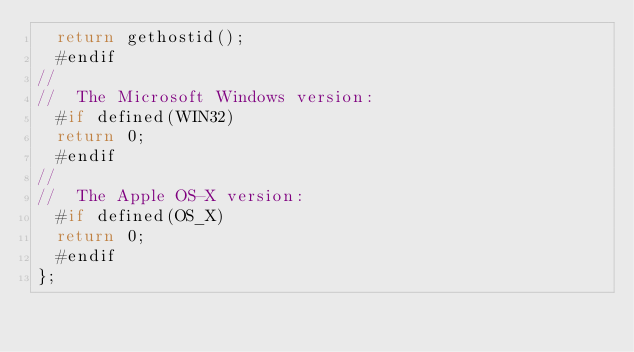Convert code to text. <code><loc_0><loc_0><loc_500><loc_500><_C++_>	return gethostid();
	#endif
//
//  The Microsoft Windows version:
	#if defined(WIN32)
	return 0;
	#endif
//
//  The Apple OS-X version:
	#if defined(OS_X)
	return 0;
	#endif
};
</code> 